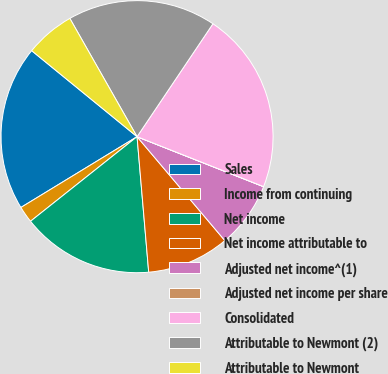<chart> <loc_0><loc_0><loc_500><loc_500><pie_chart><fcel>Sales<fcel>Income from continuing<fcel>Net income<fcel>Net income attributable to<fcel>Adjusted net income^(1)<fcel>Adjusted net income per share<fcel>Consolidated<fcel>Attributable to Newmont (2)<fcel>Attributable to Newmont<nl><fcel>19.6%<fcel>1.97%<fcel>15.68%<fcel>9.8%<fcel>7.84%<fcel>0.01%<fcel>21.56%<fcel>17.64%<fcel>5.88%<nl></chart> 